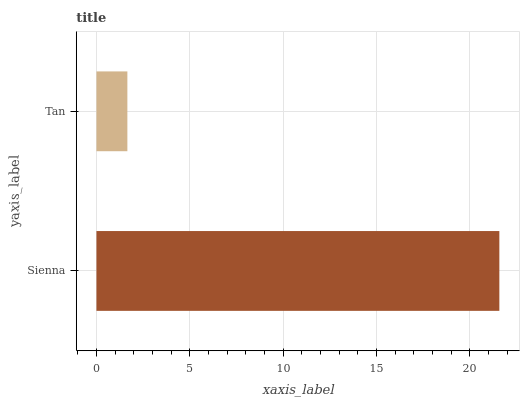Is Tan the minimum?
Answer yes or no. Yes. Is Sienna the maximum?
Answer yes or no. Yes. Is Tan the maximum?
Answer yes or no. No. Is Sienna greater than Tan?
Answer yes or no. Yes. Is Tan less than Sienna?
Answer yes or no. Yes. Is Tan greater than Sienna?
Answer yes or no. No. Is Sienna less than Tan?
Answer yes or no. No. Is Sienna the high median?
Answer yes or no. Yes. Is Tan the low median?
Answer yes or no. Yes. Is Tan the high median?
Answer yes or no. No. Is Sienna the low median?
Answer yes or no. No. 